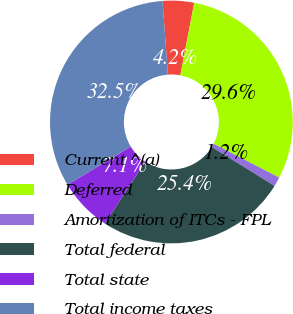Convert chart. <chart><loc_0><loc_0><loc_500><loc_500><pie_chart><fcel>Current ^(a)<fcel>Deferred<fcel>Amortization of ITCs - FPL<fcel>Total federal<fcel>Total state<fcel>Total income taxes<nl><fcel>4.18%<fcel>29.56%<fcel>1.25%<fcel>25.41%<fcel>7.11%<fcel>32.49%<nl></chart> 